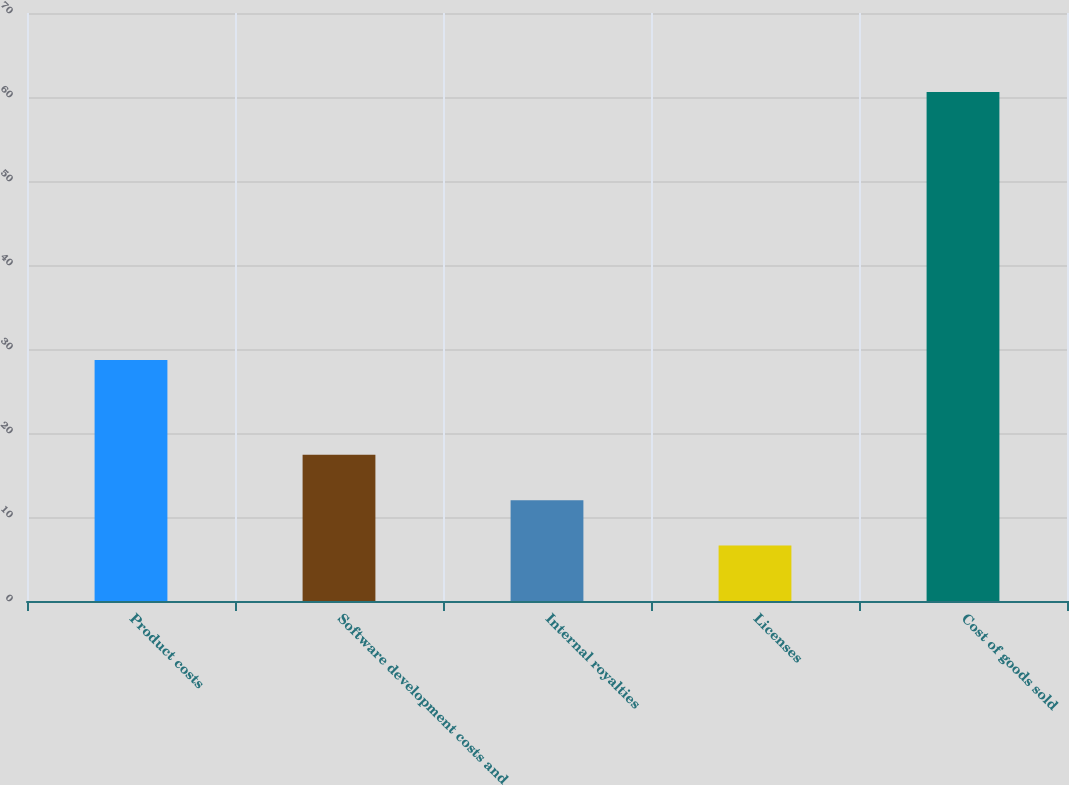Convert chart. <chart><loc_0><loc_0><loc_500><loc_500><bar_chart><fcel>Product costs<fcel>Software development costs and<fcel>Internal royalties<fcel>Licenses<fcel>Cost of goods sold<nl><fcel>28.7<fcel>17.4<fcel>12<fcel>6.6<fcel>60.6<nl></chart> 